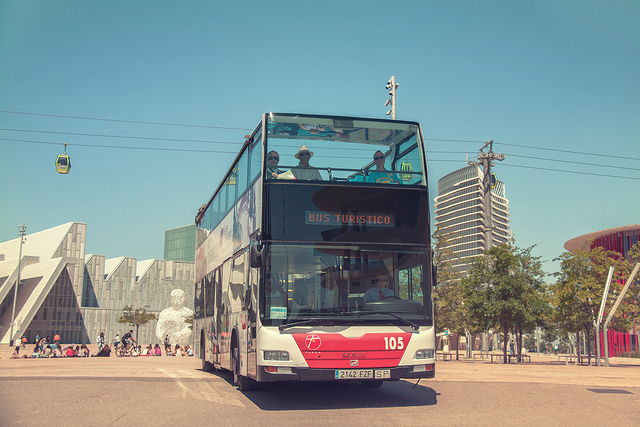<image>In what city is this scene from? It is ambiguous to determine the exact city of this scene. It could be any city like 'Toronto', 'Atlanta', 'Los Angeles', 'Miami', 'Beijing', 'San Francisco', 'Spain', 'Tokyo' or 'London'. In what city is this scene from? I don't know in what city this scene is from. It can be Toronto, Atlanta, Los Angeles, Miami, Beijing, San Francisco, Spain, Tokyo or London. 